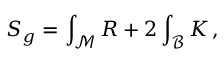Convert formula to latex. <formula><loc_0><loc_0><loc_500><loc_500>S _ { g } = \int _ { \mathcal { M } } R + 2 \int _ { \mathcal { B } } K \, ,</formula> 